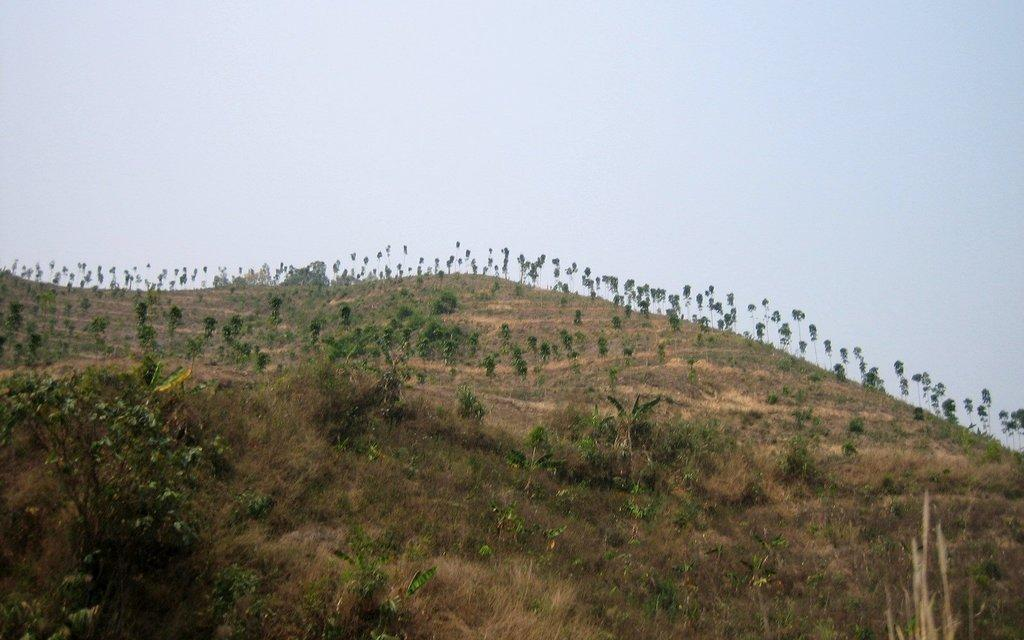What type of surface is visible in the image? There is ground visible in the image. What type of vegetation can be seen on the ground? There is grass in the image. What other natural elements are present in the image? There are trees in the image. What can be seen in the distance in the image? The sky is visible in the background of the image. Can you see the stranger's badge in the image? There is no stranger or badge present in the image. Who is the friend standing next to the trees in the image? There is no friend present in the image; only trees and other natural elements are visible. 